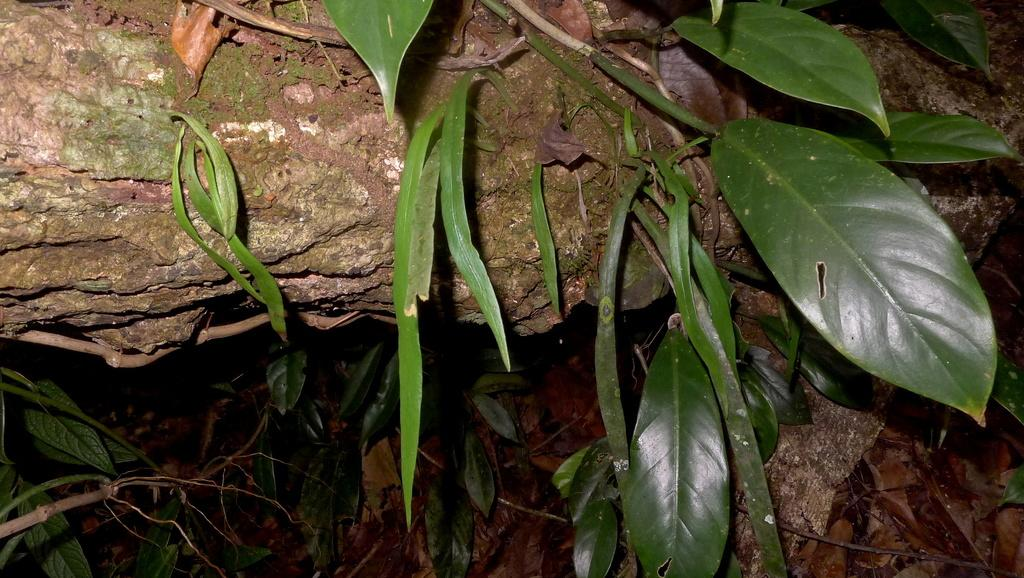What type of plant material is visible in the image? A: There are leaves on stems in the image. Can you describe the arrangement of the leaves and stems? The leaves are attached to the stems in the image. What advice does the father give to the beginner in the image? There is no father or beginner present in the image; it only features leaves on stems. 